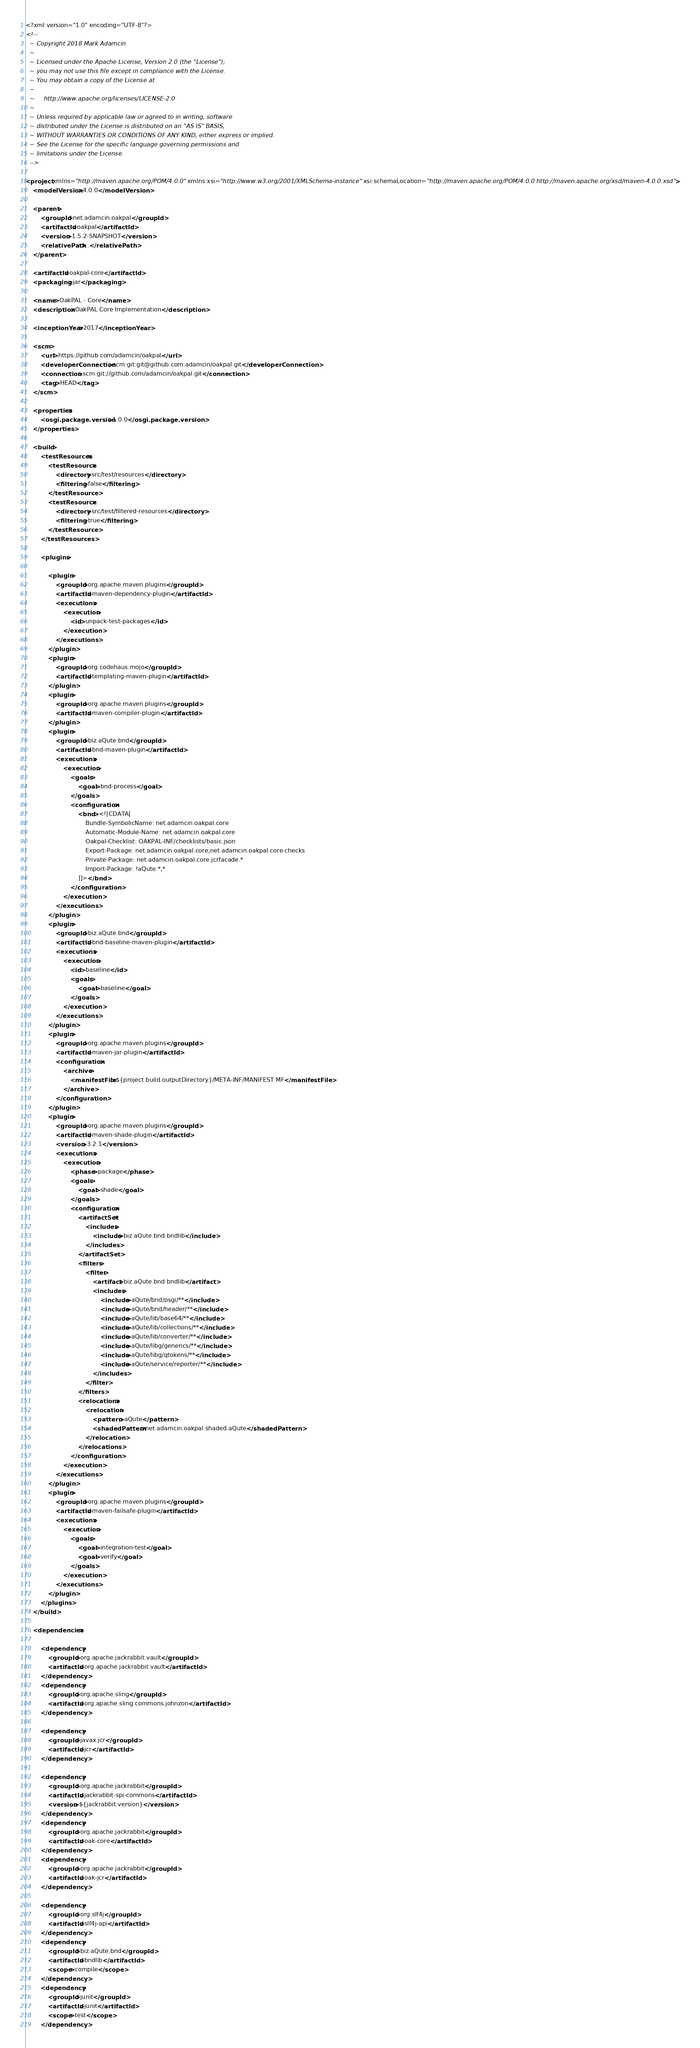<code> <loc_0><loc_0><loc_500><loc_500><_XML_><?xml version="1.0" encoding="UTF-8"?>
<!--
  ~ Copyright 2018 Mark Adamcin
  ~
  ~ Licensed under the Apache License, Version 2.0 (the "License");
  ~ you may not use this file except in compliance with the License.
  ~ You may obtain a copy of the License at
  ~
  ~     http://www.apache.org/licenses/LICENSE-2.0
  ~
  ~ Unless required by applicable law or agreed to in writing, software
  ~ distributed under the License is distributed on an "AS IS" BASIS,
  ~ WITHOUT WARRANTIES OR CONDITIONS OF ANY KIND, either express or implied.
  ~ See the License for the specific language governing permissions and
  ~ limitations under the License.
  -->

<project xmlns="http://maven.apache.org/POM/4.0.0" xmlns:xsi="http://www.w3.org/2001/XMLSchema-instance" xsi:schemaLocation="http://maven.apache.org/POM/4.0.0 http://maven.apache.org/xsd/maven-4.0.0.xsd">
    <modelVersion>4.0.0</modelVersion>

    <parent>
        <groupId>net.adamcin.oakpal</groupId>
        <artifactId>oakpal</artifactId>
        <version>1.5.2-SNAPSHOT</version>
        <relativePath>..</relativePath>
    </parent>

    <artifactId>oakpal-core</artifactId>
    <packaging>jar</packaging>

    <name>OakPAL - Core</name>
    <description>OakPAL Core Implementation</description>

    <inceptionYear>2017</inceptionYear>

    <scm>
        <url>https://github.com/adamcin/oakpal</url>
        <developerConnection>scm:git:git@github.com:adamcin/oakpal.git</developerConnection>
        <connection>scm:git://github.com/adamcin/oakpal.git</connection>
        <tag>HEAD</tag>
    </scm>

    <properties>
        <osgi.package.version>1.0.0</osgi.package.version>
    </properties>

    <build>
        <testResources>
            <testResource>
                <directory>src/test/resources</directory>
                <filtering>false</filtering>
            </testResource>
            <testResource>
                <directory>src/test/filtered-resources</directory>
                <filtering>true</filtering>
            </testResource>
        </testResources>

        <plugins>

            <plugin>
                <groupId>org.apache.maven.plugins</groupId>
                <artifactId>maven-dependency-plugin</artifactId>
                <executions>
                    <execution>
                        <id>unpack-test-packages</id>
                    </execution>
                </executions>
            </plugin>
            <plugin>
                <groupId>org.codehaus.mojo</groupId>
                <artifactId>templating-maven-plugin</artifactId>
            </plugin>
            <plugin>
                <groupId>org.apache.maven.plugins</groupId>
                <artifactId>maven-compiler-plugin</artifactId>
            </plugin>
            <plugin>
                <groupId>biz.aQute.bnd</groupId>
                <artifactId>bnd-maven-plugin</artifactId>
                <executions>
                    <execution>
                        <goals>
                            <goal>bnd-process</goal>
                        </goals>
                        <configuration>
                            <bnd><![CDATA[
                                Bundle-SymbolicName: net.adamcin.oakpal.core
                                Automatic-Module-Name: net.adamcin.oakpal.core
                                Oakpal-Checklist: OAKPAL-INF/checklists/basic.json
                                Export-Package: net.adamcin.oakpal.core,net.adamcin.oakpal.core.checks
                                Private-Package: net.adamcin.oakpal.core.jcrfacade.*
                                Import-Package: !aQute.*,*
                            ]]></bnd>
                        </configuration>
                    </execution>
                </executions>
            </plugin>
            <plugin>
                <groupId>biz.aQute.bnd</groupId>
                <artifactId>bnd-baseline-maven-plugin</artifactId>
                <executions>
                    <execution>
                        <id>baseline</id>
                        <goals>
                            <goal>baseline</goal>
                        </goals>
                    </execution>
                </executions>
            </plugin>
            <plugin>
                <groupId>org.apache.maven.plugins</groupId>
                <artifactId>maven-jar-plugin</artifactId>
                <configuration>
                    <archive>
                        <manifestFile>${project.build.outputDirectory}/META-INF/MANIFEST.MF</manifestFile>
                    </archive>
                </configuration>
            </plugin>
            <plugin>
                <groupId>org.apache.maven.plugins</groupId>
                <artifactId>maven-shade-plugin</artifactId>
                <version>3.2.1</version>
                <executions>
                    <execution>
                        <phase>package</phase>
                        <goals>
                            <goal>shade</goal>
                        </goals>
                        <configuration>
                            <artifactSet>
                                <includes>
                                    <include>biz.aQute.bnd:bndlib</include>
                                </includes>
                            </artifactSet>
                            <filters>
                                <filter>
                                    <artifact>biz.aQute.bnd:bndlib</artifact>
                                    <includes>
                                        <include>aQute/bnd/osgi/**</include>
                                        <include>aQute/bnd/header/**</include>
                                        <include>aQute/lib/base64/**</include>
                                        <include>aQute/lib/collections/**</include>
                                        <include>aQute/lib/converter/**</include>
                                        <include>aQute/libg/generics/**</include>
                                        <include>aQute/libg/qtokens/**</include>
                                        <include>aQute/service/reporter/**</include>
                                    </includes>
                                </filter>
                            </filters>
                            <relocations>
                                <relocation>
                                    <pattern>aQute</pattern>
                                    <shadedPattern>net.adamcin.oakpal.shaded.aQute</shadedPattern>
                                </relocation>
                            </relocations>
                        </configuration>
                    </execution>
                </executions>
            </plugin>
            <plugin>
                <groupId>org.apache.maven.plugins</groupId>
                <artifactId>maven-failsafe-plugin</artifactId>
                <executions>
                    <execution>
                        <goals>
                            <goal>integration-test</goal>
                            <goal>verify</goal>
                        </goals>
                    </execution>
                </executions>
            </plugin>
        </plugins>
    </build>

    <dependencies>

        <dependency>
            <groupId>org.apache.jackrabbit.vault</groupId>
            <artifactId>org.apache.jackrabbit.vault</artifactId>
        </dependency>
        <dependency>
            <groupId>org.apache.sling</groupId>
            <artifactId>org.apache.sling.commons.johnzon</artifactId>
        </dependency>

        <dependency>
            <groupId>javax.jcr</groupId>
            <artifactId>jcr</artifactId>
        </dependency>

        <dependency>
            <groupId>org.apache.jackrabbit</groupId>
            <artifactId>jackrabbit-spi-commons</artifactId>
            <version>${jackrabbit.version}</version>
        </dependency>
        <dependency>
            <groupId>org.apache.jackrabbit</groupId>
            <artifactId>oak-core</artifactId>
        </dependency>
        <dependency>
            <groupId>org.apache.jackrabbit</groupId>
            <artifactId>oak-jcr</artifactId>
        </dependency>

        <dependency>
            <groupId>org.slf4j</groupId>
            <artifactId>slf4j-api</artifactId>
        </dependency>
        <dependency>
            <groupId>biz.aQute.bnd</groupId>
            <artifactId>bndlib</artifactId>
            <scope>compile</scope>
        </dependency>
        <dependency>
            <groupId>junit</groupId>
            <artifactId>junit</artifactId>
            <scope>test</scope>
        </dependency></code> 